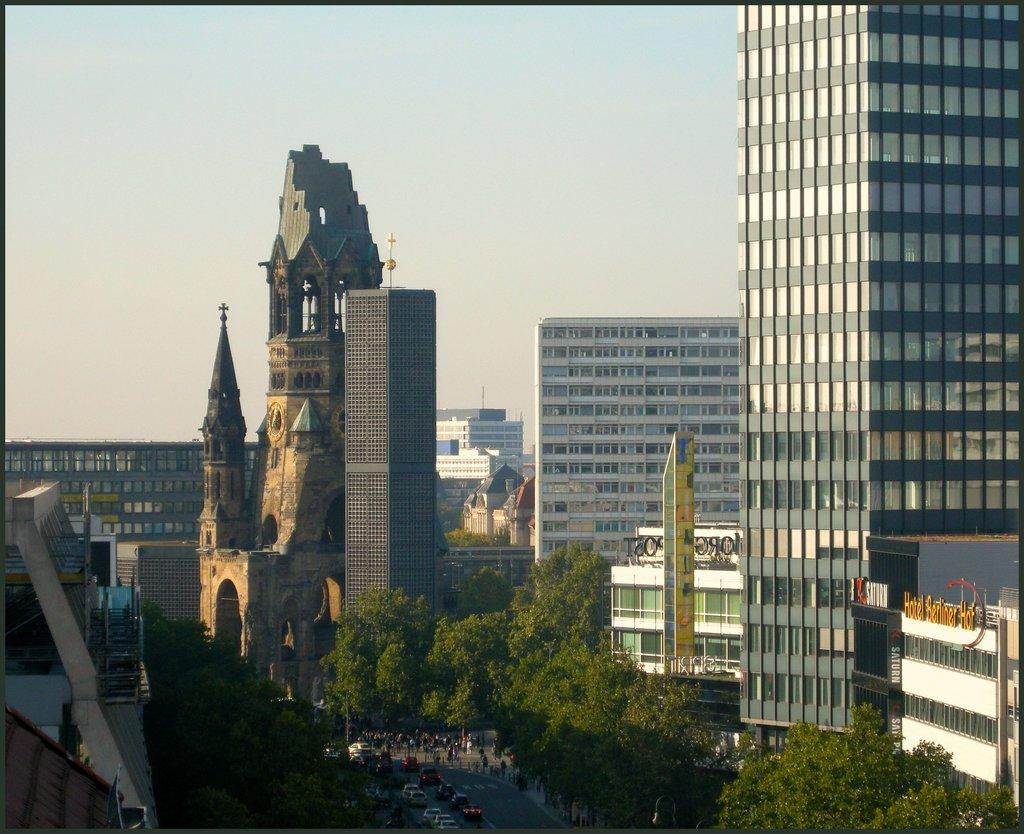What type of structures can be seen in the image? There are buildings in the image. What other natural elements are present in the image? There are trees in the image. What mode of transportation can be seen in the image? Cars are visible in the image, and they are moving on the road. What type of wrist accessory is being worn by the trees in the image? There are no wrist accessories present in the image, as the trees are natural elements and not people or animals. 